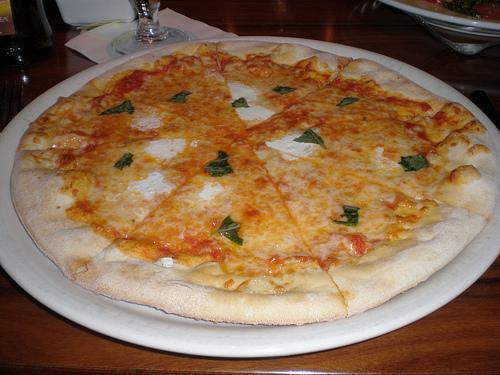How many slices are there?
Give a very brief answer. 8. How many glasses are on the table?
Give a very brief answer. 1. 